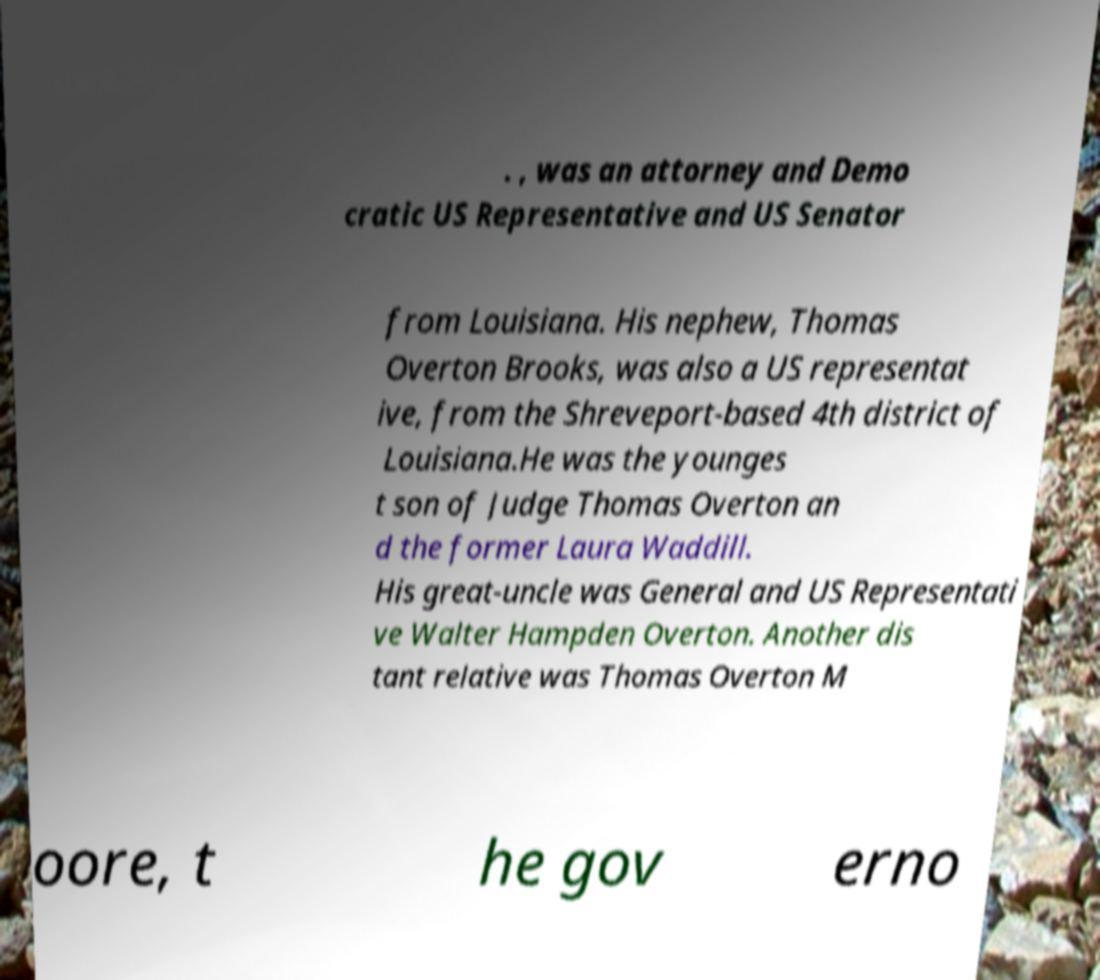Can you accurately transcribe the text from the provided image for me? . , was an attorney and Demo cratic US Representative and US Senator from Louisiana. His nephew, Thomas Overton Brooks, was also a US representat ive, from the Shreveport-based 4th district of Louisiana.He was the younges t son of Judge Thomas Overton an d the former Laura Waddill. His great-uncle was General and US Representati ve Walter Hampden Overton. Another dis tant relative was Thomas Overton M oore, t he gov erno 